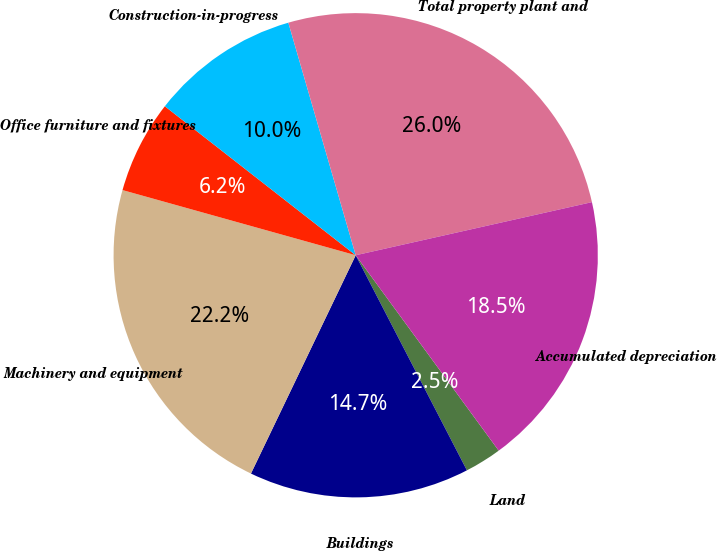Convert chart. <chart><loc_0><loc_0><loc_500><loc_500><pie_chart><fcel>Land<fcel>Buildings<fcel>Machinery and equipment<fcel>Office furniture and fixtures<fcel>Construction-in-progress<fcel>Total property plant and<fcel>Accumulated depreciation<nl><fcel>2.46%<fcel>14.71%<fcel>22.21%<fcel>6.21%<fcel>9.96%<fcel>25.96%<fcel>18.46%<nl></chart> 